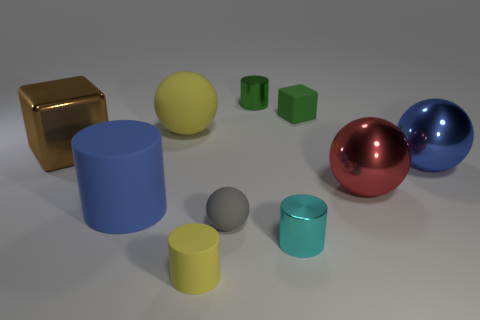Subtract 1 balls. How many balls are left? 3 Subtract all blocks. How many objects are left? 8 Subtract all large cyan metallic cubes. Subtract all cyan things. How many objects are left? 9 Add 1 matte spheres. How many matte spheres are left? 3 Add 5 big blue cylinders. How many big blue cylinders exist? 6 Subtract 0 purple spheres. How many objects are left? 10 